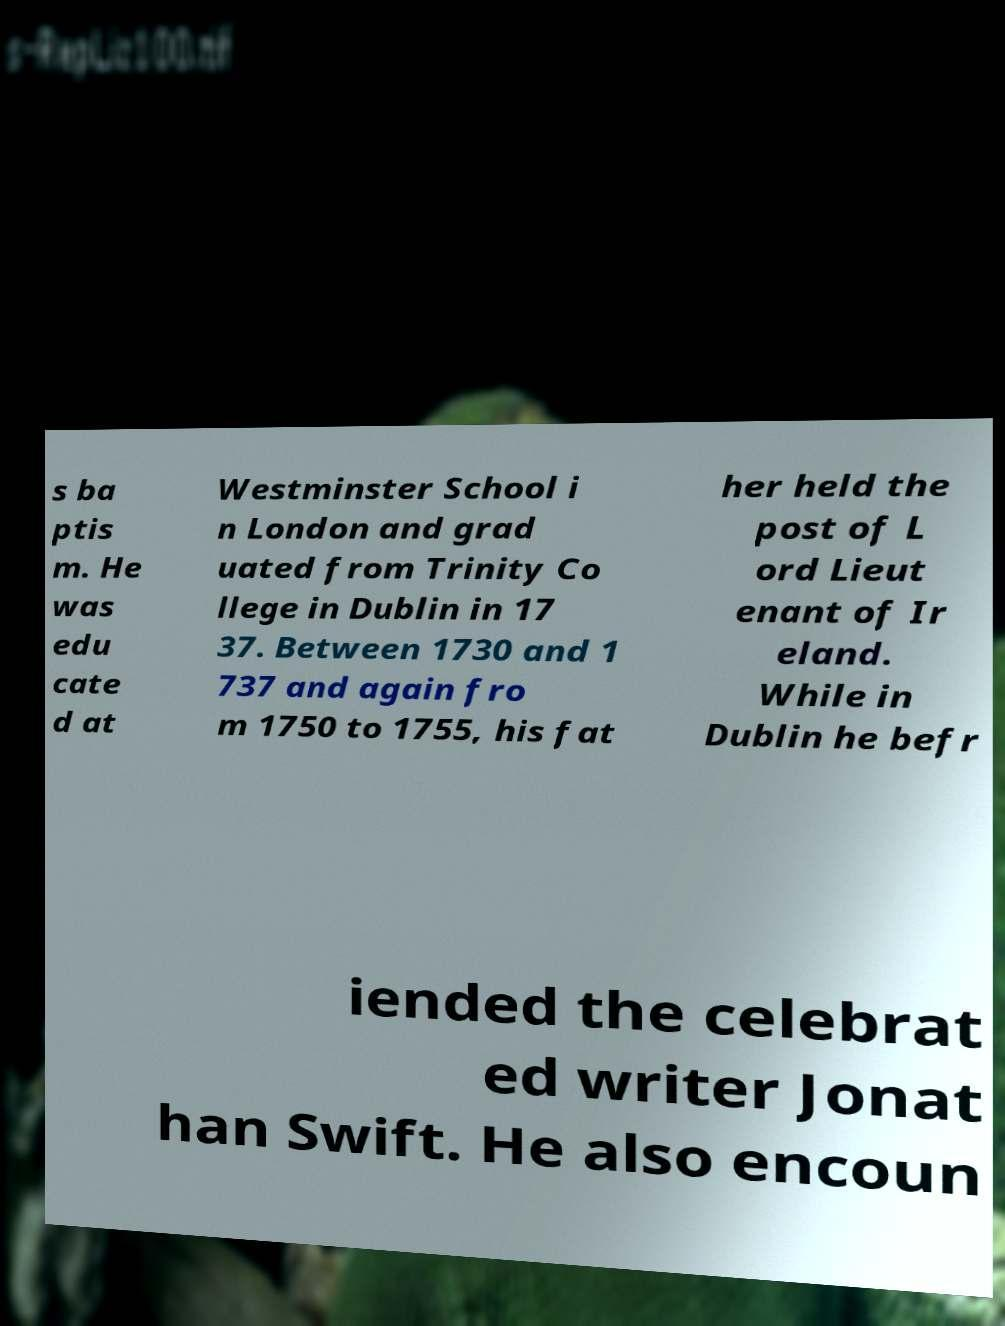Could you assist in decoding the text presented in this image and type it out clearly? s ba ptis m. He was edu cate d at Westminster School i n London and grad uated from Trinity Co llege in Dublin in 17 37. Between 1730 and 1 737 and again fro m 1750 to 1755, his fat her held the post of L ord Lieut enant of Ir eland. While in Dublin he befr iended the celebrat ed writer Jonat han Swift. He also encoun 